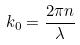Convert formula to latex. <formula><loc_0><loc_0><loc_500><loc_500>k _ { 0 } = \frac { 2 \pi n } { \lambda }</formula> 